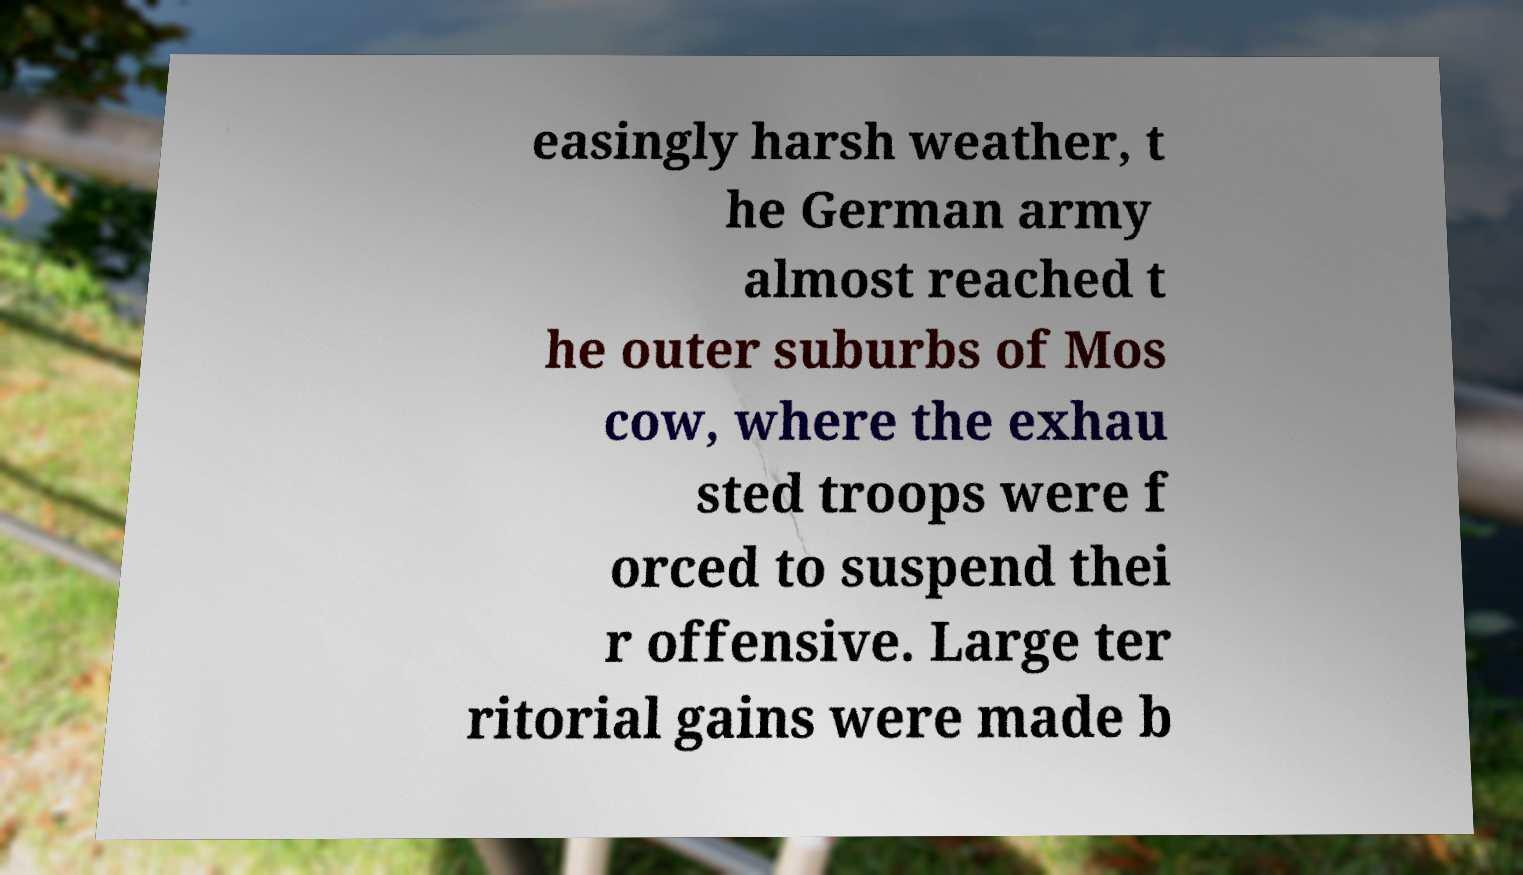For documentation purposes, I need the text within this image transcribed. Could you provide that? easingly harsh weather, t he German army almost reached t he outer suburbs of Mos cow, where the exhau sted troops were f orced to suspend thei r offensive. Large ter ritorial gains were made b 